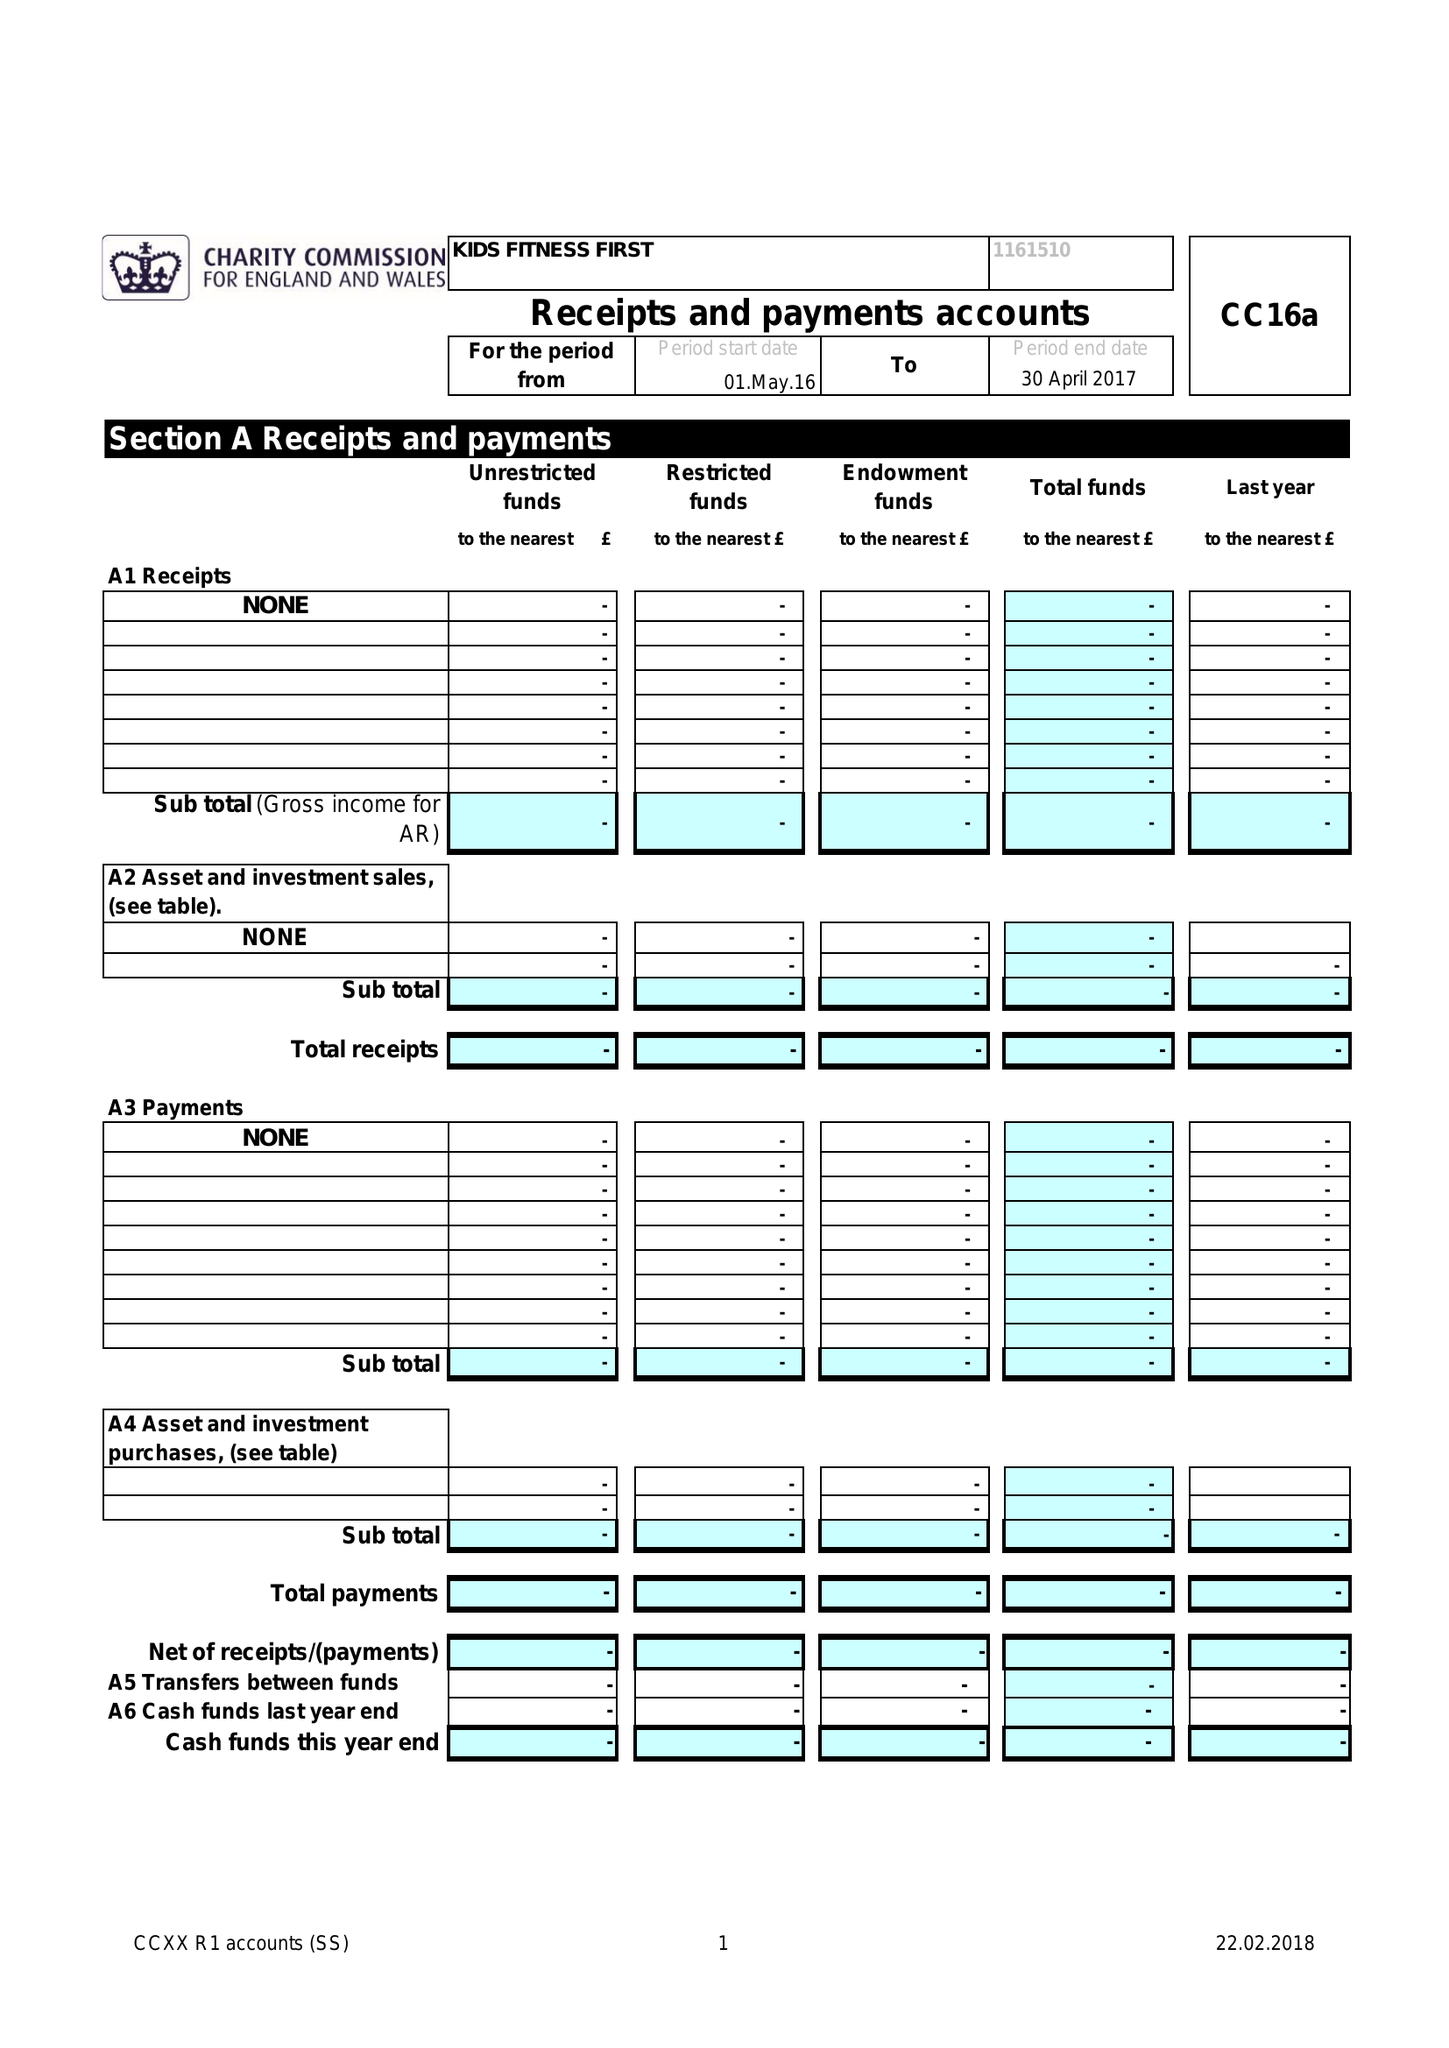What is the value for the address__post_town?
Answer the question using a single word or phrase. MANCHESTER 